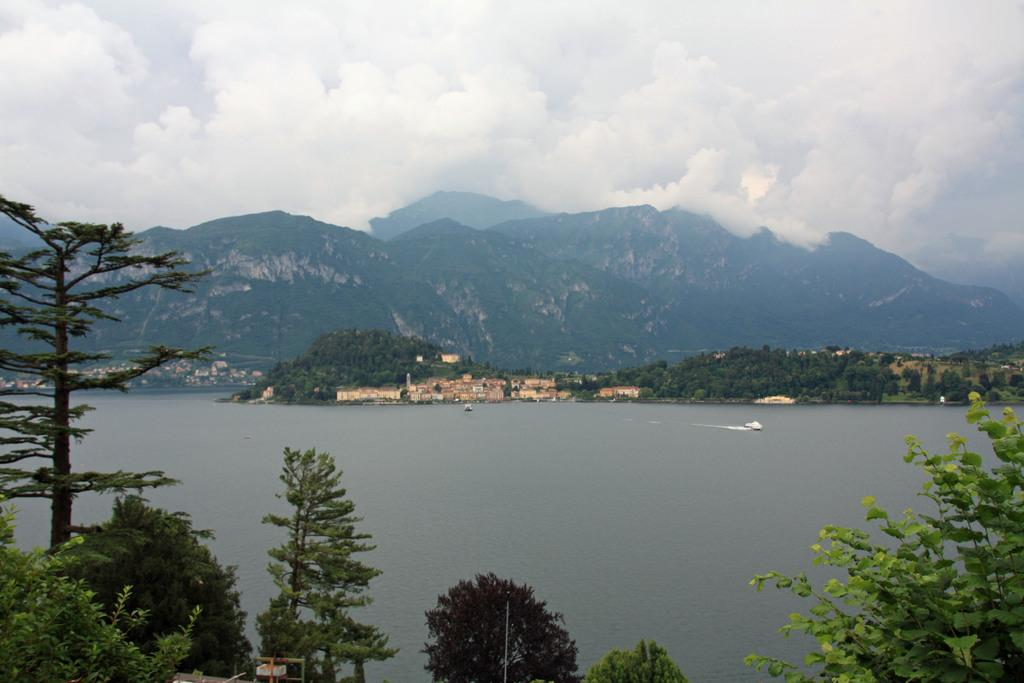What is the main element in the image? There is water in the image. What can be seen on the sides of the water? There are trees on the sides of the water. What is visible in the background of the image? There are trees, hills, and the sky in the background of the image. What is the condition of the sky in the image? Clouds are present in the sky. Where is the beggar wearing a hat in the image? There is no beggar or hat present in the image. What type of curve can be seen in the water in the image? There is no curve visible in the water in the image; it appears to be a straight body of water. 